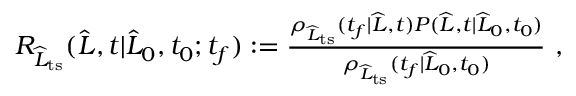<formula> <loc_0><loc_0><loc_500><loc_500>\begin{array} { r } { R _ { \widehat { L } _ { t s } } ( \widehat { L } , t | \widehat { L } _ { 0 } , t _ { 0 } ; t _ { f } ) \colon = \frac { \rho _ { \widehat { L } _ { t s } } ( t _ { f } | \widehat { L } , t ) P ( \widehat { L } , t | \widehat { L } _ { 0 } , t _ { 0 } ) } { \rho _ { \widehat { L } _ { t s } } ( t _ { f } | \widehat { L } _ { 0 } , t _ { 0 } ) } \ , } \end{array}</formula> 